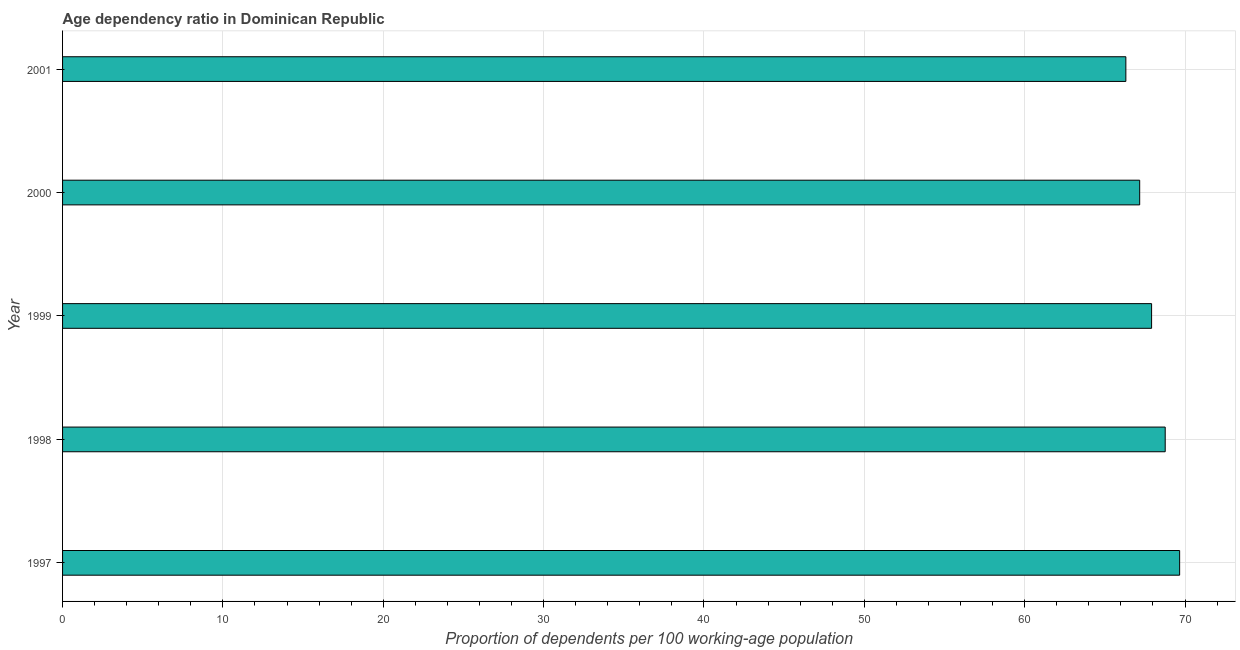Does the graph contain any zero values?
Make the answer very short. No. What is the title of the graph?
Ensure brevity in your answer.  Age dependency ratio in Dominican Republic. What is the label or title of the X-axis?
Offer a terse response. Proportion of dependents per 100 working-age population. What is the label or title of the Y-axis?
Your response must be concise. Year. What is the age dependency ratio in 2000?
Ensure brevity in your answer.  67.17. Across all years, what is the maximum age dependency ratio?
Offer a terse response. 69.66. Across all years, what is the minimum age dependency ratio?
Ensure brevity in your answer.  66.31. In which year was the age dependency ratio maximum?
Your answer should be very brief. 1997. In which year was the age dependency ratio minimum?
Your answer should be very brief. 2001. What is the sum of the age dependency ratio?
Keep it short and to the point. 339.82. What is the difference between the age dependency ratio in 2000 and 2001?
Your answer should be compact. 0.86. What is the average age dependency ratio per year?
Your answer should be very brief. 67.96. What is the median age dependency ratio?
Ensure brevity in your answer.  67.91. In how many years, is the age dependency ratio greater than 10 ?
Your response must be concise. 5. Is the age dependency ratio in 1997 less than that in 2000?
Your answer should be very brief. No. Is the difference between the age dependency ratio in 1999 and 2000 greater than the difference between any two years?
Make the answer very short. No. What is the difference between the highest and the second highest age dependency ratio?
Offer a terse response. 0.9. What is the difference between the highest and the lowest age dependency ratio?
Give a very brief answer. 3.35. In how many years, is the age dependency ratio greater than the average age dependency ratio taken over all years?
Your answer should be compact. 2. How many bars are there?
Your answer should be very brief. 5. How many years are there in the graph?
Make the answer very short. 5. What is the Proportion of dependents per 100 working-age population of 1997?
Make the answer very short. 69.66. What is the Proportion of dependents per 100 working-age population of 1998?
Your answer should be very brief. 68.76. What is the Proportion of dependents per 100 working-age population in 1999?
Your response must be concise. 67.91. What is the Proportion of dependents per 100 working-age population in 2000?
Ensure brevity in your answer.  67.17. What is the Proportion of dependents per 100 working-age population of 2001?
Your response must be concise. 66.31. What is the difference between the Proportion of dependents per 100 working-age population in 1997 and 1998?
Ensure brevity in your answer.  0.9. What is the difference between the Proportion of dependents per 100 working-age population in 1997 and 1999?
Offer a terse response. 1.75. What is the difference between the Proportion of dependents per 100 working-age population in 1997 and 2000?
Ensure brevity in your answer.  2.49. What is the difference between the Proportion of dependents per 100 working-age population in 1997 and 2001?
Keep it short and to the point. 3.35. What is the difference between the Proportion of dependents per 100 working-age population in 1998 and 1999?
Your response must be concise. 0.85. What is the difference between the Proportion of dependents per 100 working-age population in 1998 and 2000?
Offer a very short reply. 1.59. What is the difference between the Proportion of dependents per 100 working-age population in 1998 and 2001?
Offer a terse response. 2.45. What is the difference between the Proportion of dependents per 100 working-age population in 1999 and 2000?
Your answer should be very brief. 0.74. What is the difference between the Proportion of dependents per 100 working-age population in 1999 and 2001?
Your answer should be compact. 1.6. What is the difference between the Proportion of dependents per 100 working-age population in 2000 and 2001?
Offer a very short reply. 0.86. What is the ratio of the Proportion of dependents per 100 working-age population in 1997 to that in 1998?
Offer a very short reply. 1.01. What is the ratio of the Proportion of dependents per 100 working-age population in 1997 to that in 2000?
Offer a very short reply. 1.04. What is the ratio of the Proportion of dependents per 100 working-age population in 1997 to that in 2001?
Offer a terse response. 1.05. What is the ratio of the Proportion of dependents per 100 working-age population in 1998 to that in 1999?
Your answer should be compact. 1.01. What is the ratio of the Proportion of dependents per 100 working-age population in 1998 to that in 2001?
Provide a succinct answer. 1.04. What is the ratio of the Proportion of dependents per 100 working-age population in 2000 to that in 2001?
Provide a succinct answer. 1.01. 